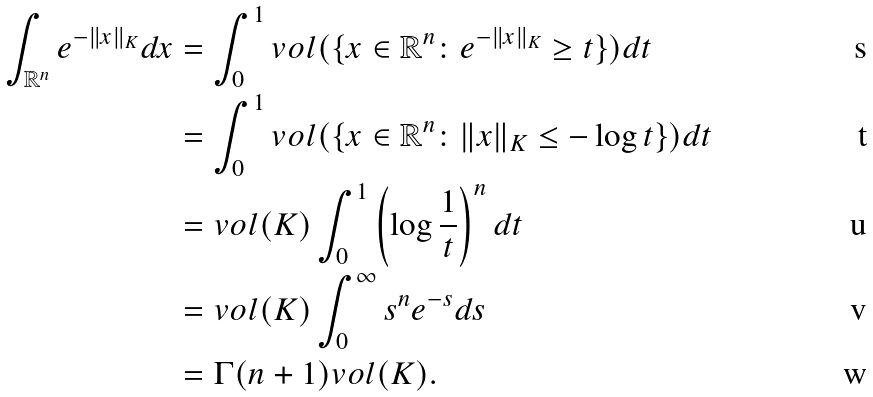<formula> <loc_0><loc_0><loc_500><loc_500>\int _ { \mathbb { R } ^ { n } } e ^ { - \| x \| _ { K } } d x & = \int _ { 0 } ^ { 1 } v o l ( \{ x \in \mathbb { R } ^ { n } \colon e ^ { - \| x \| _ { K } } \geq t \} ) d t \\ & = \int _ { 0 } ^ { 1 } v o l ( \{ x \in \mathbb { R } ^ { n } \colon \| x \| _ { K } \leq - \log t \} ) d t \\ & = v o l ( K ) \int _ { 0 } ^ { 1 } \left ( \log \frac { 1 } { t } \right ) ^ { n } d t \\ & = v o l ( K ) \int _ { 0 } ^ { \infty } s ^ { n } e ^ { - s } d s \\ & = \Gamma ( n + 1 ) v o l ( K ) .</formula> 